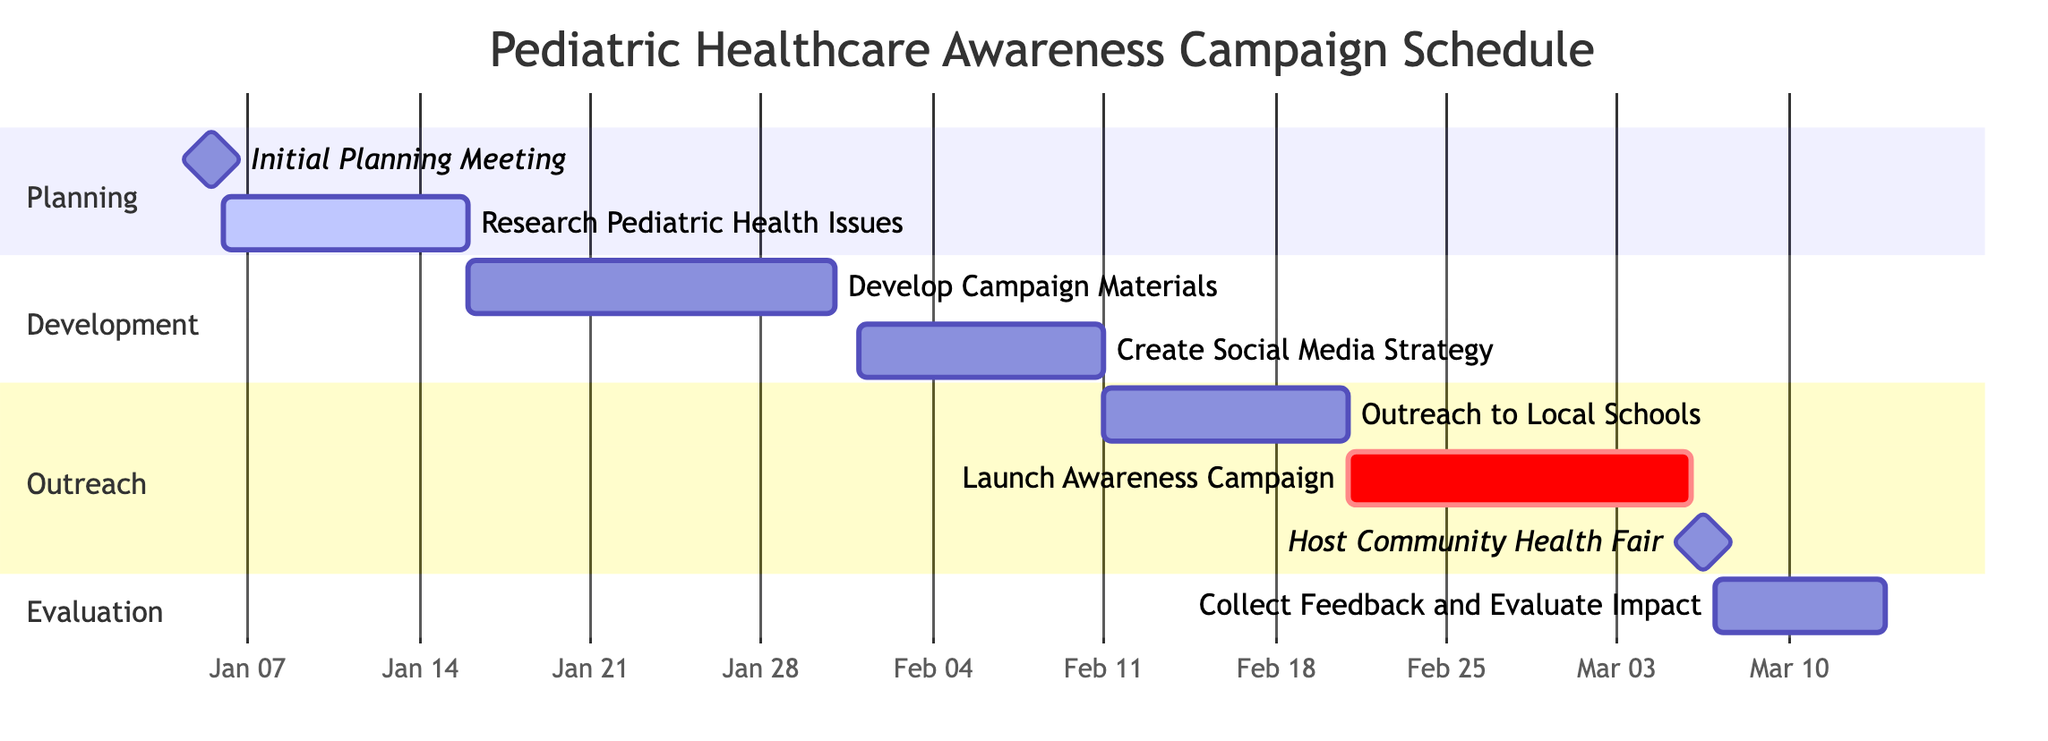What is the duration of the "Initial Planning Meeting"? The task "Initial Planning Meeting" has a duration of 1 day, as indicated in the diagram.
Answer: 1 day When does the "Research Pediatric Health Issues" task start? The task "Research Pediatric Health Issues" starts on January 6, 2024, as shown in the diagram.
Answer: January 6, 2024 How many tasks are in the "Outreach" section? There are three tasks listed under the "Outreach" section: "Outreach to Local Schools", "Launch Awareness Campaign", and "Host Community Health Fair", totaling three tasks.
Answer: 3 What is the end date of the "Launch Awareness Campaign"? The "Launch Awareness Campaign" ends on March 5, 2024, according to the task’s end date in the diagram.
Answer: March 5, 2024 Which task directly follows the "Create Social Media Strategy"? The task that directly follows "Create Social Media Strategy" is "Outreach to Local Schools", as indicated by their sequential placement in the Gantt Chart.
Answer: Outreach to Local Schools What is the total duration of the tasks in the "Development" section? The "Development" section includes two tasks: "Develop Campaign Materials" with a duration of 15 days and "Create Social Media Strategy" with a duration of 10 days. Adding these together (15 + 10) gives a total duration of 25 days.
Answer: 25 days Which task starts last among the main tasks? The task "Collect Feedback and Evaluate Impact" starts on March 7, 2024, which is the latest start date among all tasks in the schedule.
Answer: Collect Feedback and Evaluate Impact What milestone is scheduled on March 6, 2024? The "Host Community Health Fair" is scheduled as a milestone on March 6, 2024, as indicated in the timeline.
Answer: Host Community Health Fair 